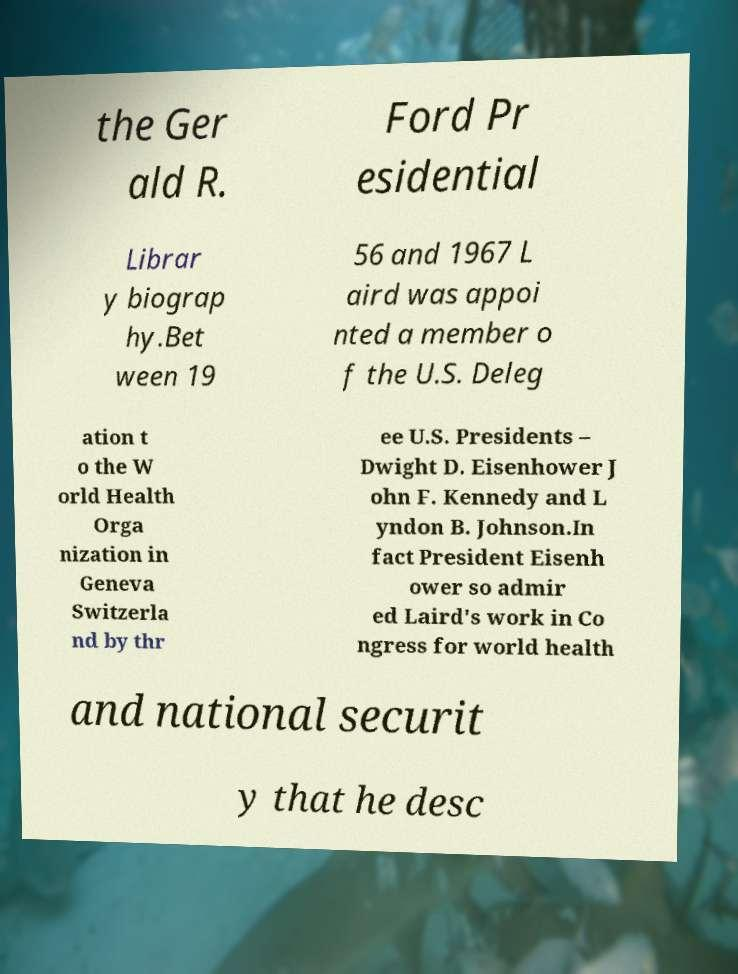Can you read and provide the text displayed in the image?This photo seems to have some interesting text. Can you extract and type it out for me? the Ger ald R. Ford Pr esidential Librar y biograp hy.Bet ween 19 56 and 1967 L aird was appoi nted a member o f the U.S. Deleg ation t o the W orld Health Orga nization in Geneva Switzerla nd by thr ee U.S. Presidents – Dwight D. Eisenhower J ohn F. Kennedy and L yndon B. Johnson.In fact President Eisenh ower so admir ed Laird's work in Co ngress for world health and national securit y that he desc 